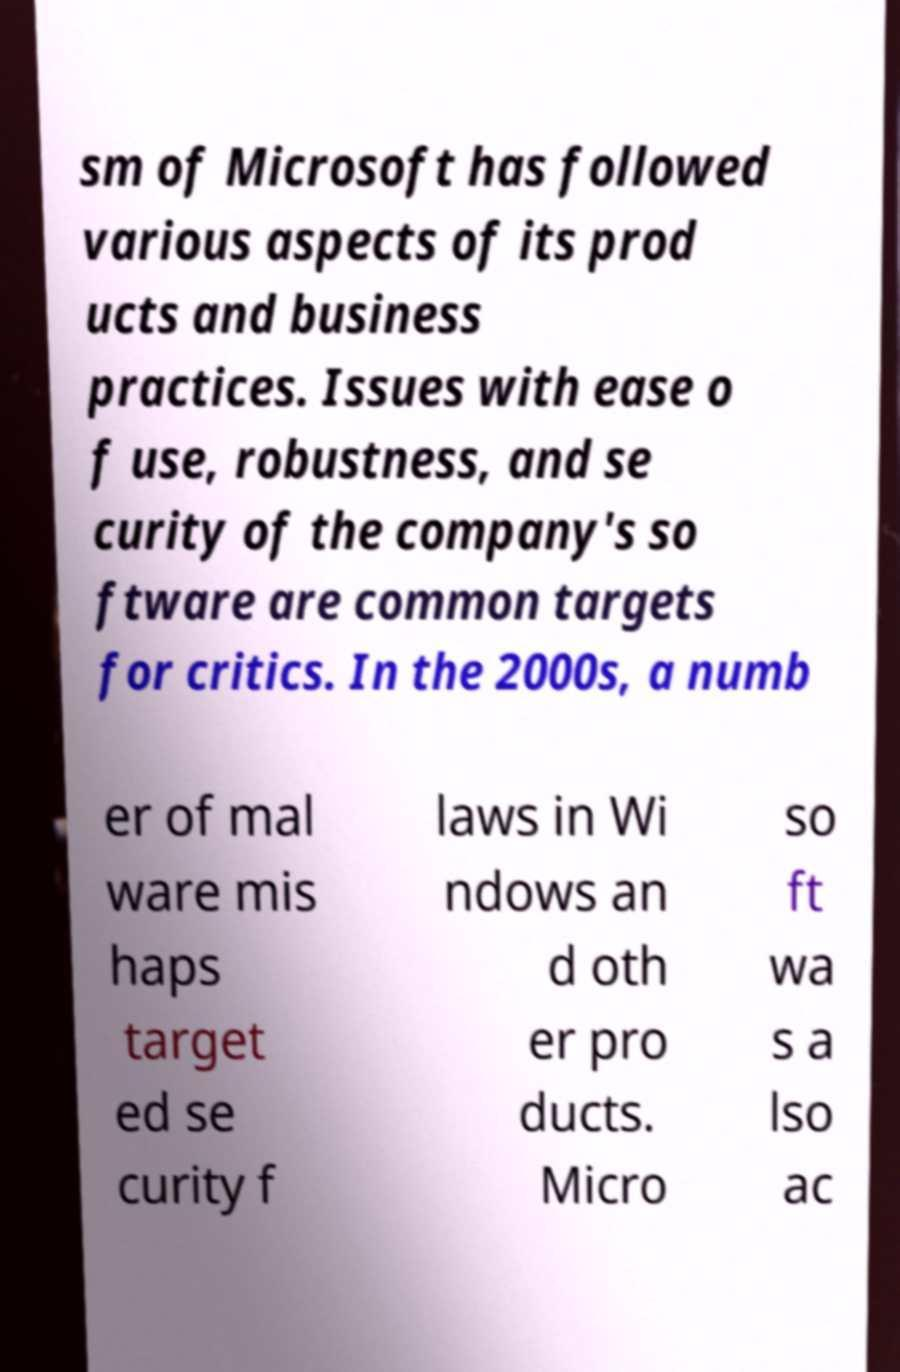Please identify and transcribe the text found in this image. sm of Microsoft has followed various aspects of its prod ucts and business practices. Issues with ease o f use, robustness, and se curity of the company's so ftware are common targets for critics. In the 2000s, a numb er of mal ware mis haps target ed se curity f laws in Wi ndows an d oth er pro ducts. Micro so ft wa s a lso ac 